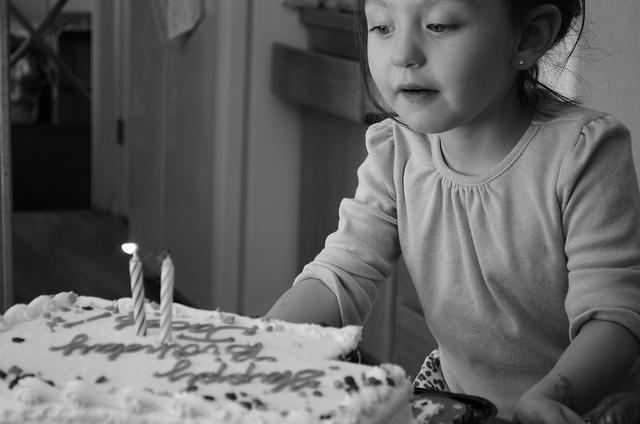How many candles are on the cake?
Give a very brief answer. 2. How many layers does the cake have?
Give a very brief answer. 1. How many layers are in the cake?
Give a very brief answer. 1. How many slices is she cutting?
Give a very brief answer. 1. How many candles on the cake?
Give a very brief answer. 2. How many different desserts are there?
Give a very brief answer. 1. How many candles are on the food?
Give a very brief answer. 2. How many people are in the picture?
Give a very brief answer. 1. How many glass bottles are on the ledge behind the stove?
Give a very brief answer. 0. 